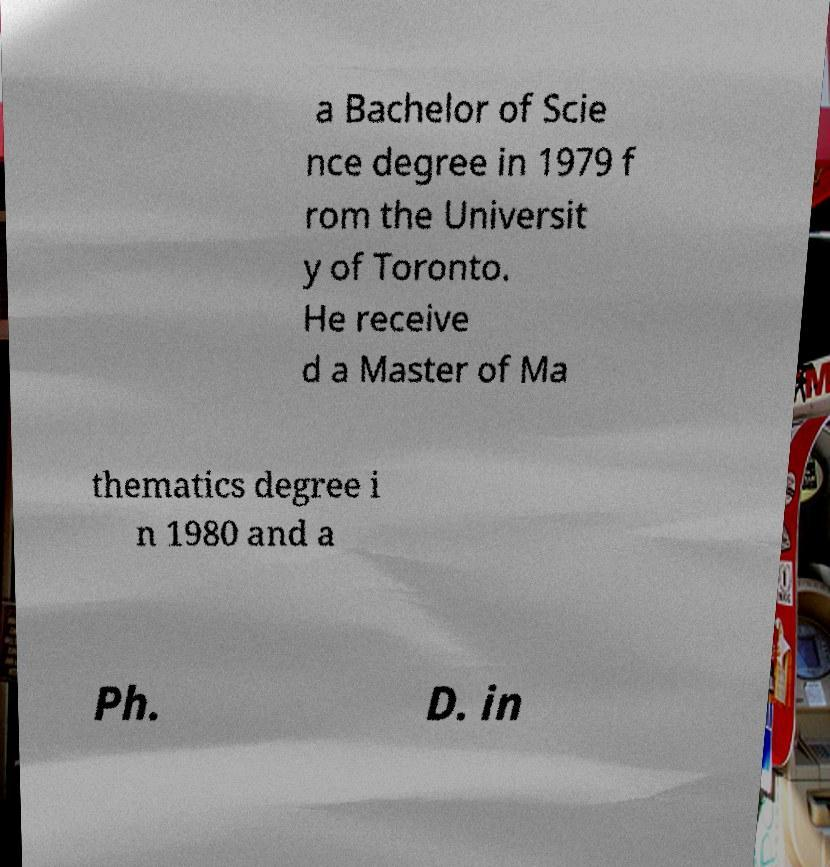Could you assist in decoding the text presented in this image and type it out clearly? a Bachelor of Scie nce degree in 1979 f rom the Universit y of Toronto. He receive d a Master of Ma thematics degree i n 1980 and a Ph. D. in 